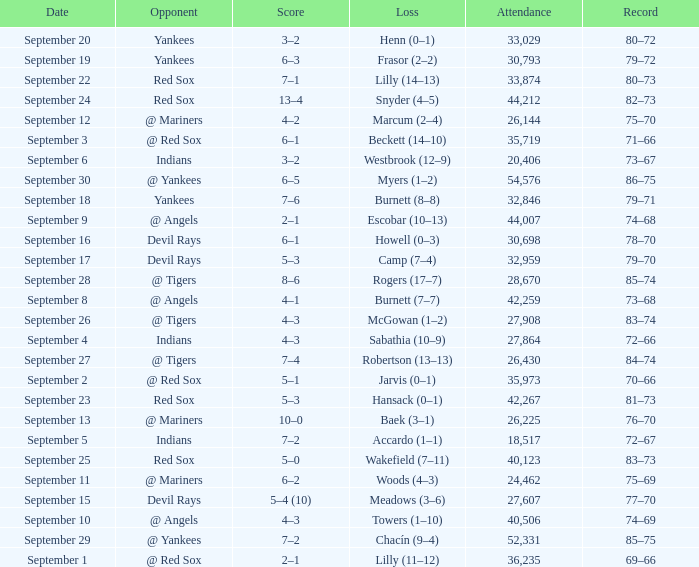Which opponent plays on September 19? Yankees. 